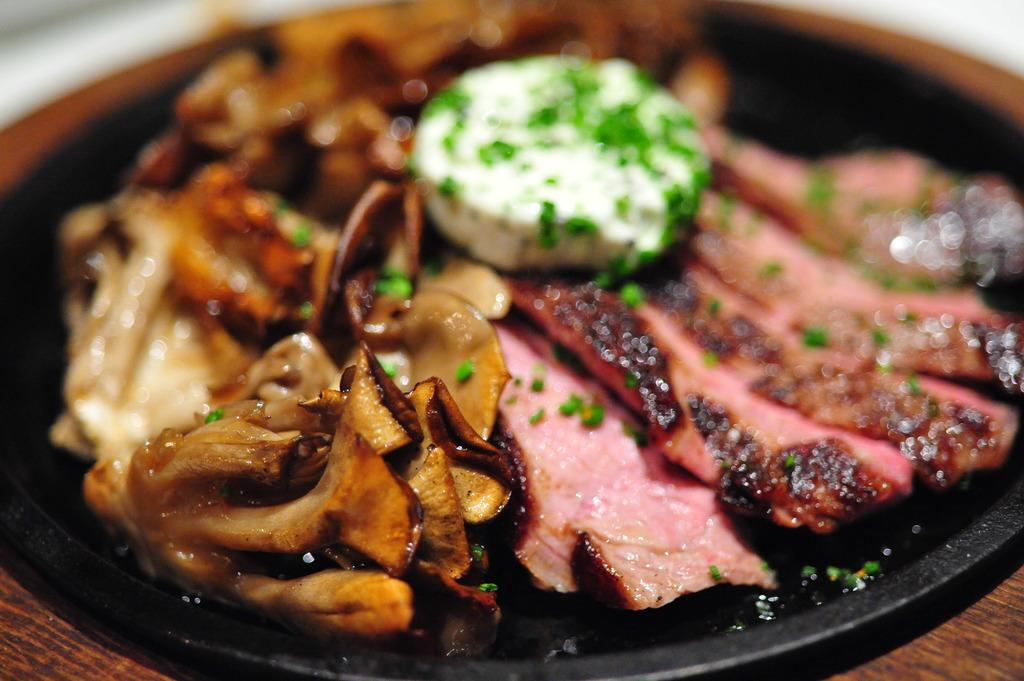What is the main subject of the image? The main subject of the image is food. What is the food placed on? The food is on a black-colored pan. What type of legal advice is the carpenter providing in the image? There is no carpenter or legal advice present in the image; it only features food on a black-colored pan. 